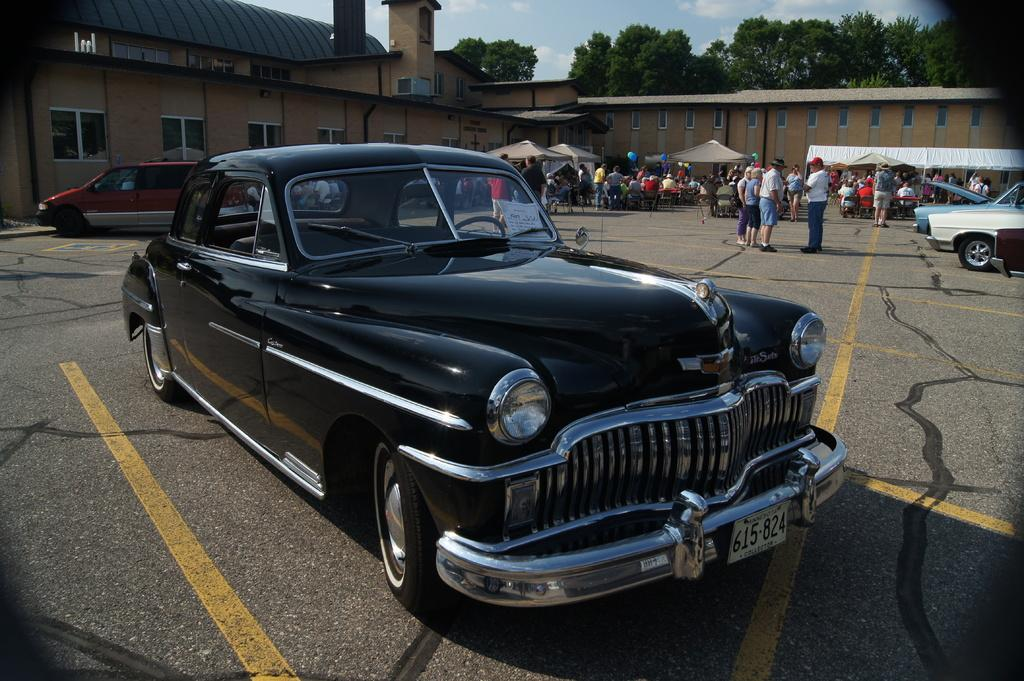What type of vehicle is in the foreground of the image? There is a black color car in the foreground of the image. What can be seen in the background of the image? The sky is visible in the background of the image. What type of marble is used to decorate the car's interior in the image? There is no mention of marble or the car's interior in the image, so it cannot be determined from the image. 